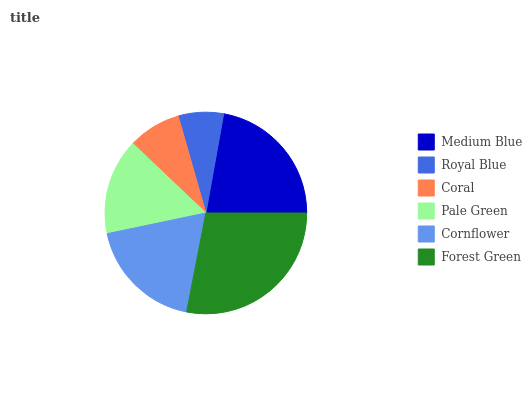Is Royal Blue the minimum?
Answer yes or no. Yes. Is Forest Green the maximum?
Answer yes or no. Yes. Is Coral the minimum?
Answer yes or no. No. Is Coral the maximum?
Answer yes or no. No. Is Coral greater than Royal Blue?
Answer yes or no. Yes. Is Royal Blue less than Coral?
Answer yes or no. Yes. Is Royal Blue greater than Coral?
Answer yes or no. No. Is Coral less than Royal Blue?
Answer yes or no. No. Is Cornflower the high median?
Answer yes or no. Yes. Is Pale Green the low median?
Answer yes or no. Yes. Is Coral the high median?
Answer yes or no. No. Is Cornflower the low median?
Answer yes or no. No. 